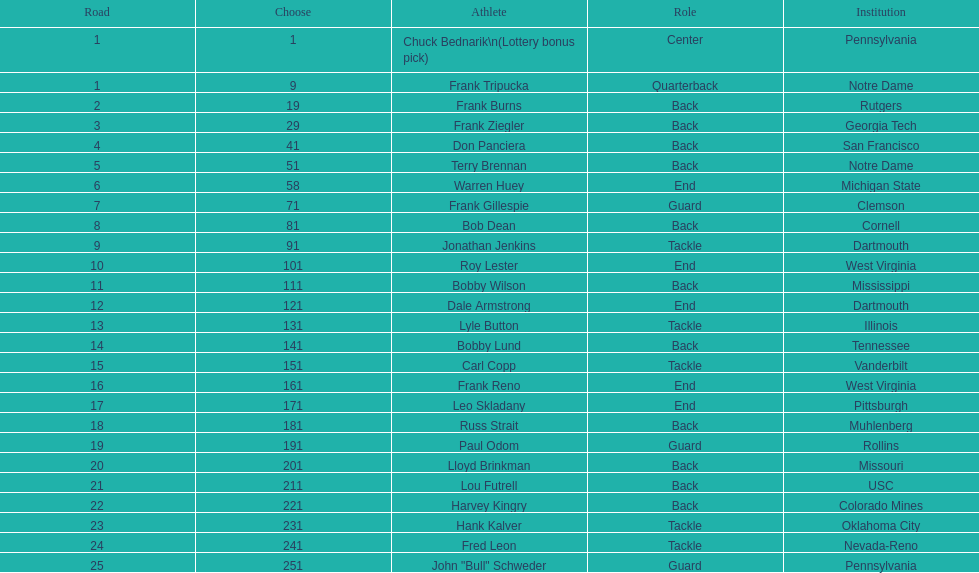How many players were from notre dame? 2. 